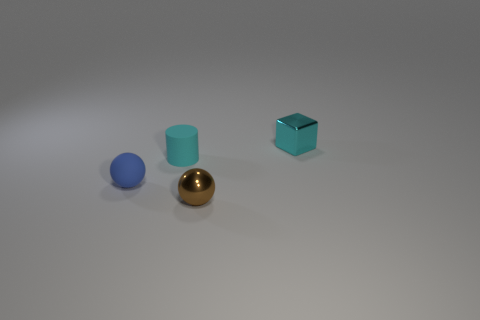Imagine these objects are part of a game, what could be the objective involving these items? In a creative game scenario, these items could represent different elements in a puzzle. The objective might be to arrange them according to specific rules. For example, players might need to order them by size or material, use the reflective properties of the metal objects to direct a beam of light, or balance the cylindrical object atop the sphere. Each object's distinct shape and material could contribute uniquely to the challenge, requiring players to think strategically about their physical properties. 